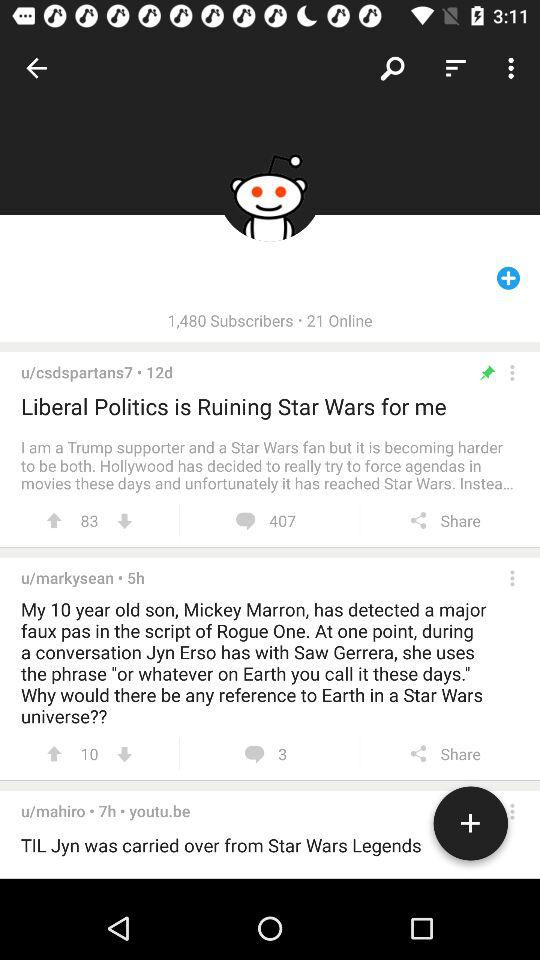How many people are online? There are 21 people online. 